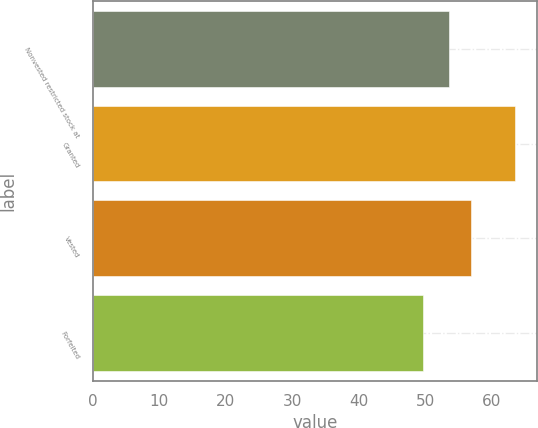Convert chart to OTSL. <chart><loc_0><loc_0><loc_500><loc_500><bar_chart><fcel>Nonvested restricted stock at<fcel>Granted<fcel>Vested<fcel>Forfeited<nl><fcel>53.61<fcel>63.59<fcel>56.93<fcel>49.65<nl></chart> 